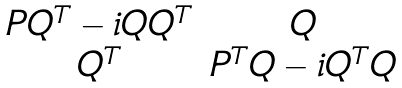<formula> <loc_0><loc_0><loc_500><loc_500>\begin{matrix} P Q ^ { T } - i Q Q ^ { T } & Q \\ Q ^ { T } & P ^ { T } Q - i Q ^ { T } Q \end{matrix}</formula> 